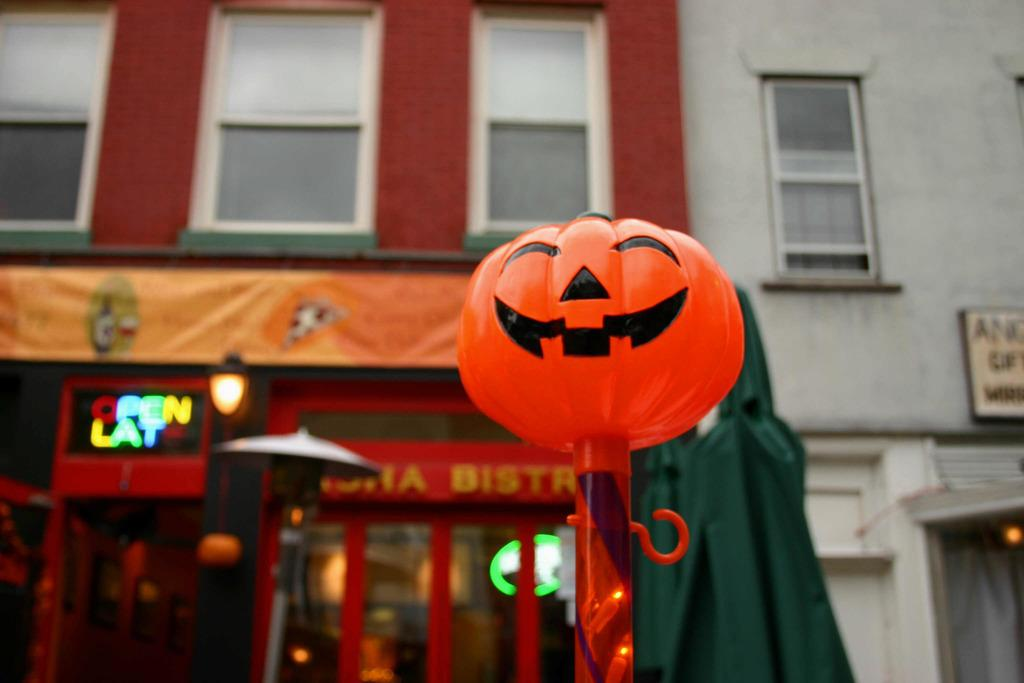What type of decoration is featured in the image? There is an artificial Halloween pumpkin in the image. How is the pumpkin displayed? The pumpkin is attached to a pole. What can be seen behind the pole? There is a store behind the pole. What is located above the store? There is a building above the store. Can you see any fish swimming in the image? No, there are no fish present in the image. What type of machine is being used to create the pumpkin? The image does not show any machines or manufacturing processes; it simply depicts a finished artificial pumpkin. 